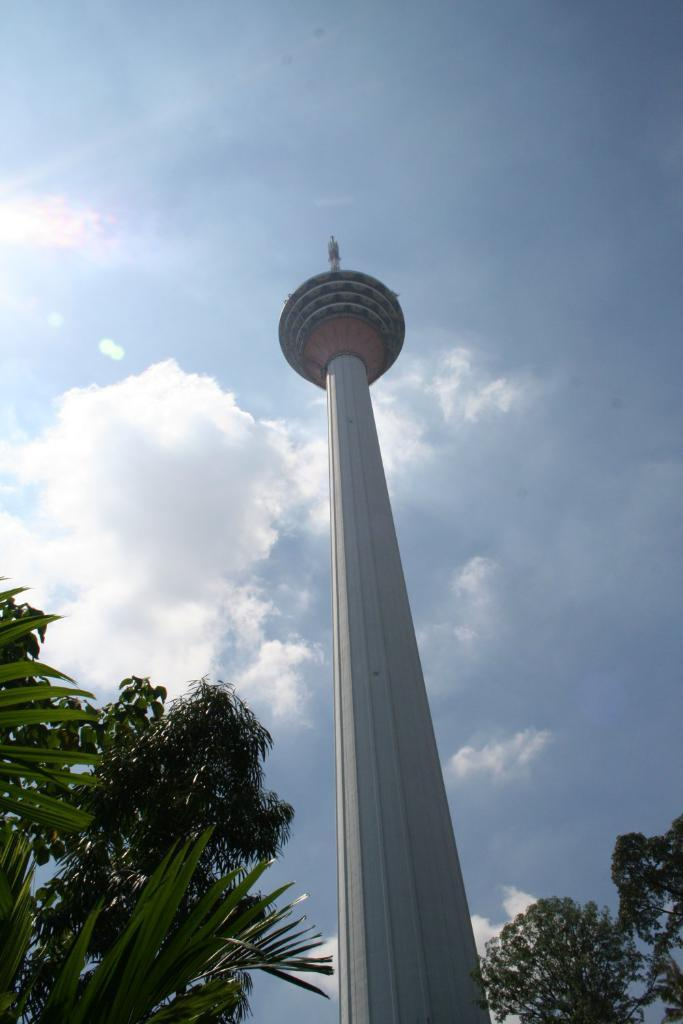Where was the picture taken? The picture was clicked outside. What can be seen in the foreground of the image? There are trees in the foreground of the image. What is the main architectural feature in the image? There is a minaret in the center of the image. What is visible in the background of the image? The sky is visible in the background of the image. What is the weather like in the image? The presence of clouds in the sky suggests that it might be partly cloudy. What channel is the cat watching during lunch in the image? There are no cats or lunch depicted in the image; it features a minaret and trees. 